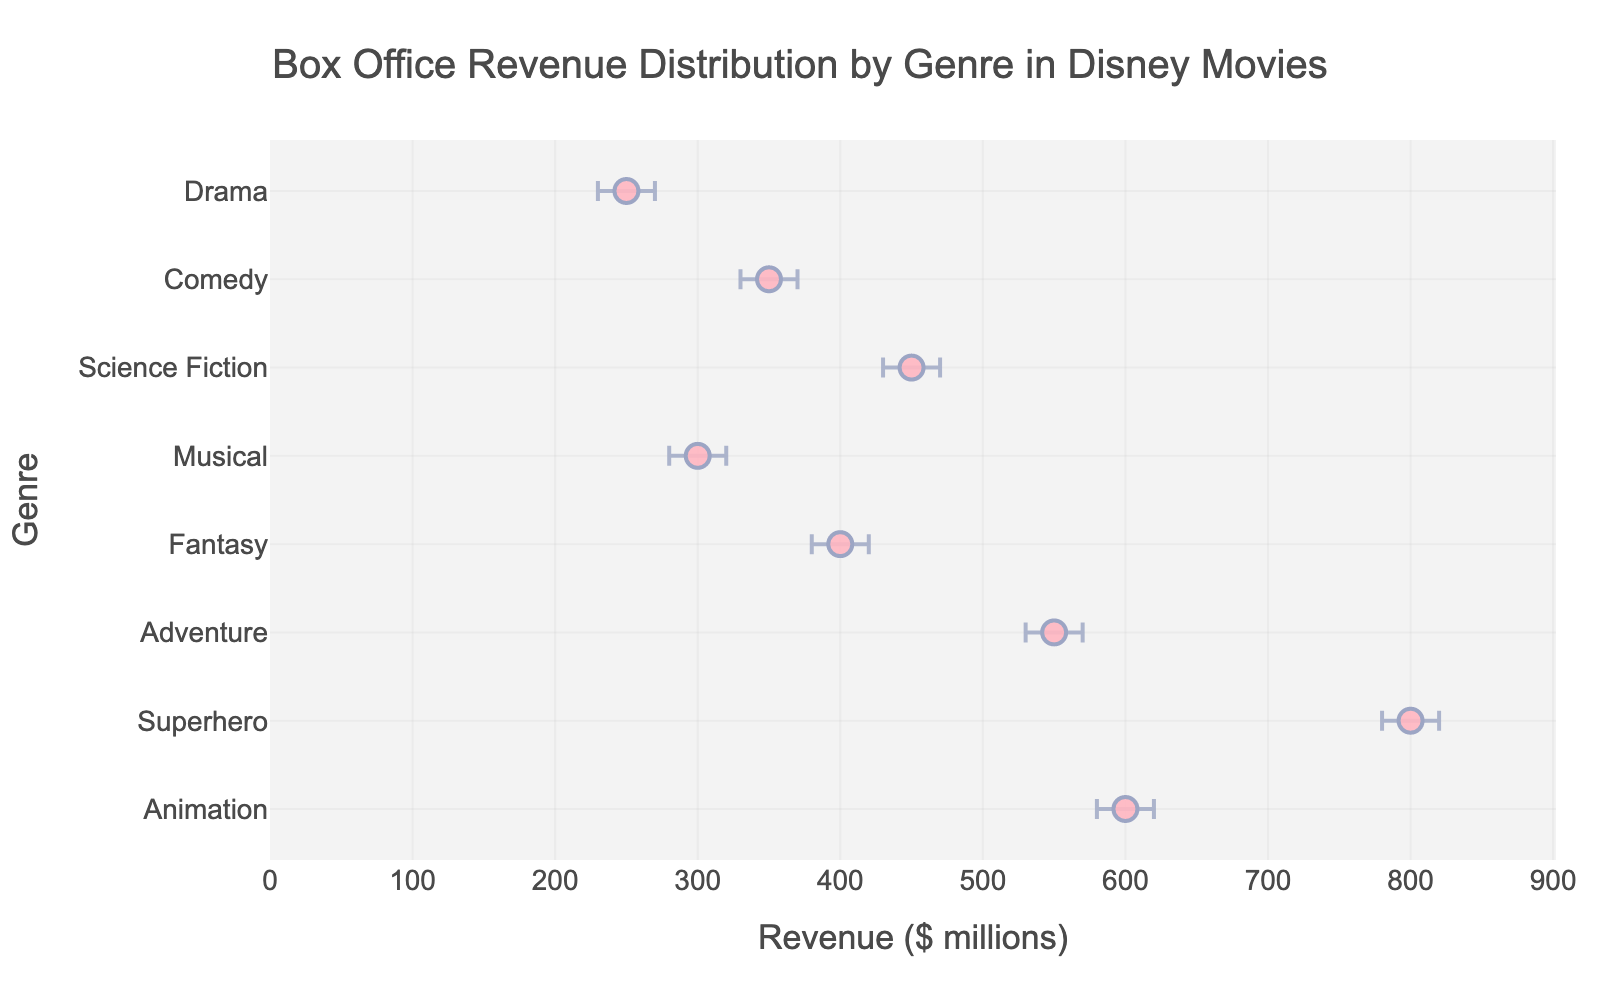How many genres are analyzed in the figure? The Y-axis of the figure represents the genres analyzed. By counting the number of unique genres listed, we can determine the total number.
Answer: 8 Which genre has the highest mean box office revenue, and what is it? The X-axis of the figure represents the mean revenue, and we observe the data points. The genre with the highest mean revenue will be the rightmost point on the chart.
Answer: Superhero, $800 million Which three genres have the lowest mean box office revenues? By examining the placement of the data points on the X-axis, the three genres with the leftmost positions will have the lowest revenues.
Answer: Drama, Musical, Comedy What's the difference in mean revenue between the Animation and Fantasy genres? Locate the mean revenue for both genres and subtract the smaller from the larger: 600 (Animation) - 400 (Fantasy) = 200
Answer: $200 million Compare the uncertainty (error margins) for the Adventure and Science Fiction genres. Which one has a wider error margin? Calculate the error margins for both genres using the difference between their upper and lower bounds. Adventure: 570 - 530 = 40, Science Fiction: 470 - 430 = 40. Both have the same error margin.
Answer: Neither, both are equal Which genre shows the smallest uncertainty in mean revenue and what is the value? The smallest uncertainty (narrowest error bars) can be found by identifying the difference between upper and lower bounds for each genre and choosing the smallest.
Answer: Animation, 40 If we consider a genre to be highly variable if the difference in its error margins exceeds 50% of its mean revenue, which genre(s) qualify? Calculate 50% of the mean revenue for each genre, then check if the error margin exceeds this value. None of the genres have error margins exceeding 50% of their mean revenue: Animation = 50% of 600 = 300, error margin is 40; etc.
Answer: None Which genre has the highest lower bound for its box office revenue? Reference the specific lower bounds for each genre and choose the largest one.
Answer: Superhero, $780 million 